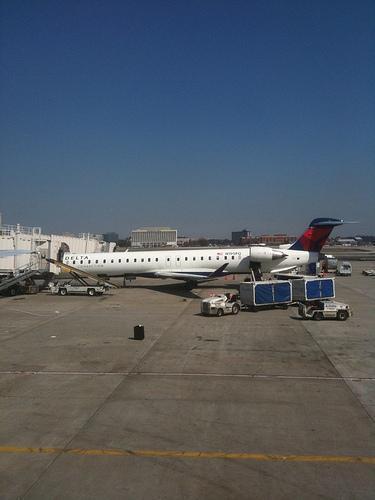How many airplanes are there?
Give a very brief answer. 1. 